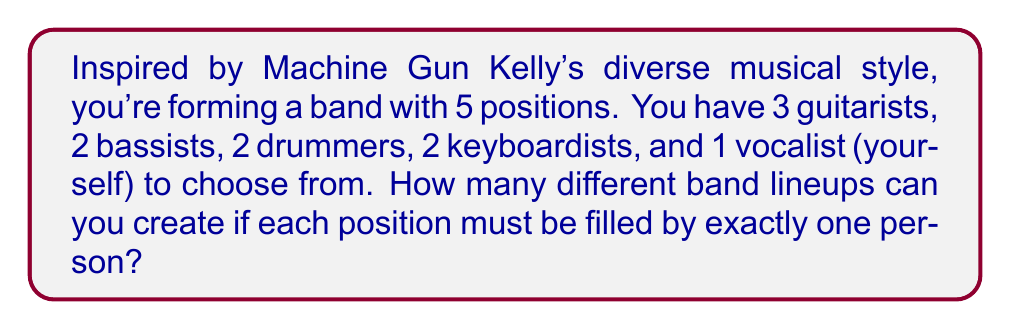Solve this math problem. Let's approach this step-by-step using the multiplication principle of combinatorics:

1) For the guitar position, we have 3 choices.

2) For the bass position, we have 2 choices.

3) For the drums position, we have 2 choices.

4) For the keyboard position, we have 2 choices.

5) For the vocalist position, there's only 1 choice (yourself).

According to the multiplication principle, if we have a series of independent choices, the total number of ways to make these choices is the product of the number of ways to make each individual choice.

Therefore, the total number of different band lineups is:

$$3 \times 2 \times 2 \times 2 \times 1 = 24$$

This can also be written as:

$$\binom{3}{1} \times \binom{2}{1} \times \binom{2}{1} \times \binom{2}{1} \times \binom{1}{1} = 24$$

Where $\binom{n}{k}$ represents the number of ways to choose $k$ items from $n$ items.
Answer: 24 